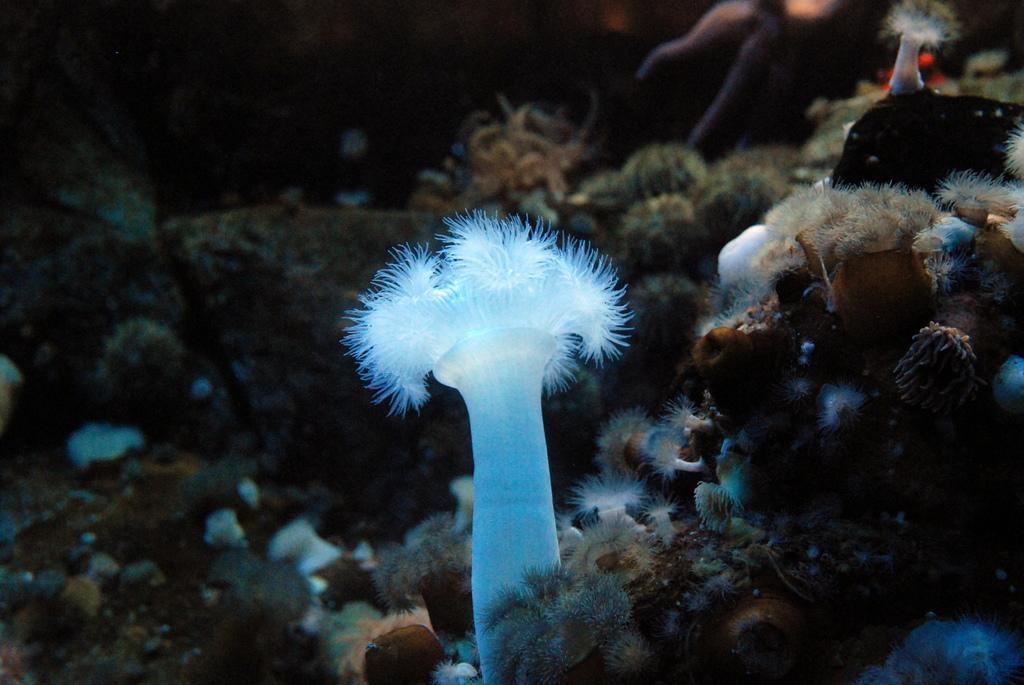Please provide a concise description of this image. In this image I can see few aquatic plants, background I can see few stones. 